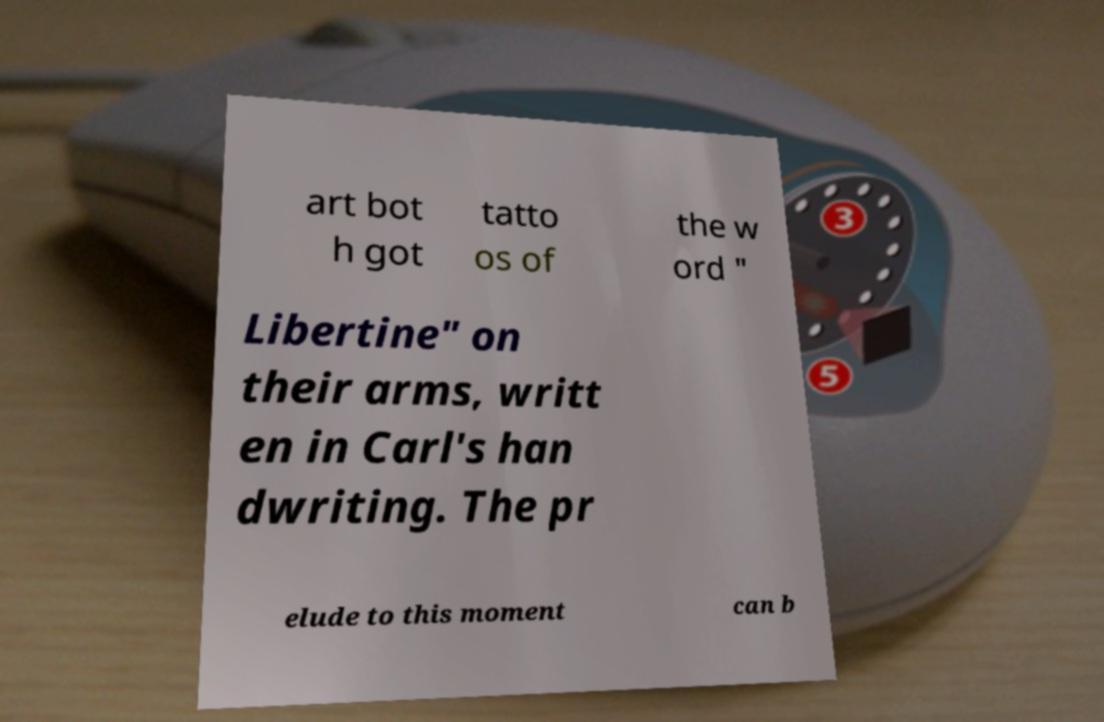For documentation purposes, I need the text within this image transcribed. Could you provide that? art bot h got tatto os of the w ord " Libertine" on their arms, writt en in Carl's han dwriting. The pr elude to this moment can b 